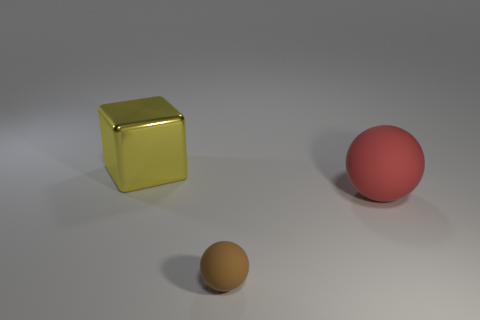How many red objects have the same size as the yellow metal thing?
Make the answer very short. 1. Do the tiny thing and the large red object have the same shape?
Provide a short and direct response. Yes. The sphere behind the brown object in front of the large red thing is what color?
Give a very brief answer. Red. What size is the object that is behind the tiny brown matte ball and left of the big ball?
Offer a terse response. Large. The small brown object that is made of the same material as the red thing is what shape?
Your response must be concise. Sphere. There is a red object; does it have the same shape as the rubber object that is in front of the big rubber thing?
Your answer should be compact. Yes. What is the large thing on the left side of the thing right of the tiny brown ball made of?
Your response must be concise. Metal. Is the number of things in front of the large yellow metal block the same as the number of small brown metallic cubes?
Your answer should be compact. No. Are there any other things that are the same material as the big cube?
Provide a short and direct response. No. How many objects are on the left side of the big ball and in front of the yellow block?
Your answer should be compact. 1. 